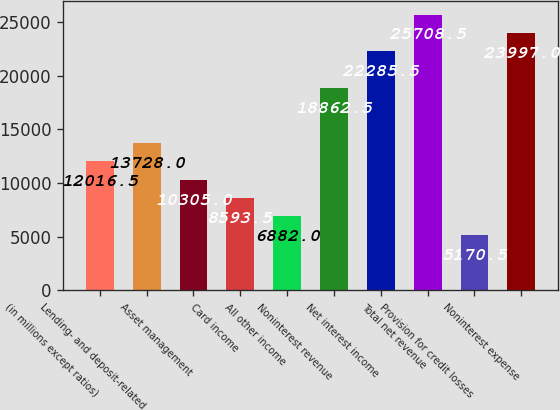<chart> <loc_0><loc_0><loc_500><loc_500><bar_chart><fcel>(in millions except ratios)<fcel>Lending- and deposit-related<fcel>Asset management<fcel>Card income<fcel>All other income<fcel>Noninterest revenue<fcel>Net interest income<fcel>Total net revenue<fcel>Provision for credit losses<fcel>Noninterest expense<nl><fcel>12016.5<fcel>13728<fcel>10305<fcel>8593.5<fcel>6882<fcel>18862.5<fcel>22285.5<fcel>25708.5<fcel>5170.5<fcel>23997<nl></chart> 